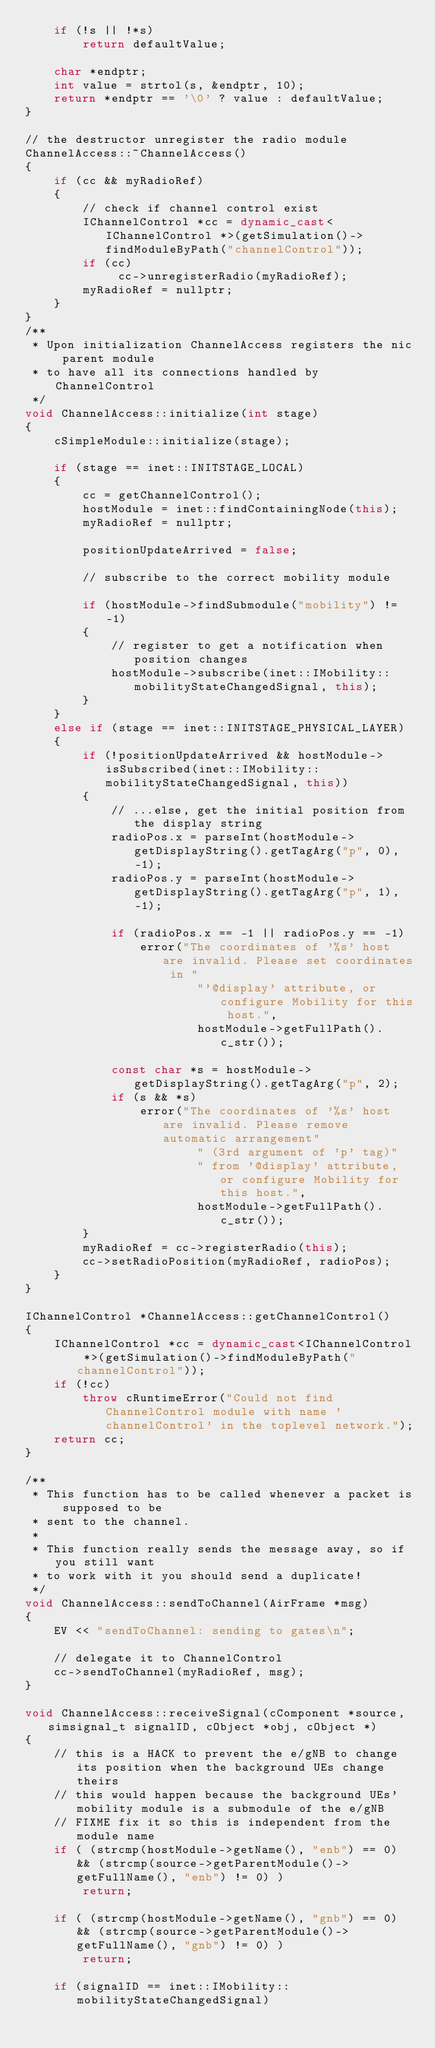Convert code to text. <code><loc_0><loc_0><loc_500><loc_500><_C++_>    if (!s || !*s)
        return defaultValue;

    char *endptr;
    int value = strtol(s, &endptr, 10);
    return *endptr == '\0' ? value : defaultValue;
}

// the destructor unregister the radio module
ChannelAccess::~ChannelAccess()
{
    if (cc && myRadioRef)
    {
        // check if channel control exist
        IChannelControl *cc = dynamic_cast<IChannelControl *>(getSimulation()->findModuleByPath("channelControl"));
        if (cc)
             cc->unregisterRadio(myRadioRef);
        myRadioRef = nullptr;
    }
}
/**
 * Upon initialization ChannelAccess registers the nic parent module
 * to have all its connections handled by ChannelControl
 */
void ChannelAccess::initialize(int stage)
{
    cSimpleModule::initialize(stage);

    if (stage == inet::INITSTAGE_LOCAL)
    {
        cc = getChannelControl();
        hostModule = inet::findContainingNode(this);
        myRadioRef = nullptr;

        positionUpdateArrived = false;

        // subscribe to the correct mobility module

        if (hostModule->findSubmodule("mobility") != -1)
        {
            // register to get a notification when position changes
            hostModule->subscribe(inet::IMobility::mobilityStateChangedSignal, this);
        }
    }
    else if (stage == inet::INITSTAGE_PHYSICAL_LAYER)
    {
        if (!positionUpdateArrived && hostModule->isSubscribed(inet::IMobility::mobilityStateChangedSignal, this))
        {
            // ...else, get the initial position from the display string
            radioPos.x = parseInt(hostModule->getDisplayString().getTagArg("p", 0), -1);
            radioPos.y = parseInt(hostModule->getDisplayString().getTagArg("p", 1), -1);

            if (radioPos.x == -1 || radioPos.y == -1)
                error("The coordinates of '%s' host are invalid. Please set coordinates in "
                        "'@display' attribute, or configure Mobility for this host.",
                        hostModule->getFullPath().c_str());

            const char *s = hostModule->getDisplayString().getTagArg("p", 2);
            if (s && *s)
                error("The coordinates of '%s' host are invalid. Please remove automatic arrangement"
                        " (3rd argument of 'p' tag)"
                        " from '@display' attribute, or configure Mobility for this host.",
                        hostModule->getFullPath().c_str());
        }
        myRadioRef = cc->registerRadio(this);
        cc->setRadioPosition(myRadioRef, radioPos);
    }
}

IChannelControl *ChannelAccess::getChannelControl()
{
    IChannelControl *cc = dynamic_cast<IChannelControl *>(getSimulation()->findModuleByPath("channelControl"));
    if (!cc)
        throw cRuntimeError("Could not find ChannelControl module with name 'channelControl' in the toplevel network.");
    return cc;
}

/**
 * This function has to be called whenever a packet is supposed to be
 * sent to the channel.
 *
 * This function really sends the message away, so if you still want
 * to work with it you should send a duplicate!
 */
void ChannelAccess::sendToChannel(AirFrame *msg)
{
    EV << "sendToChannel: sending to gates\n";

    // delegate it to ChannelControl
    cc->sendToChannel(myRadioRef, msg);
}

void ChannelAccess::receiveSignal(cComponent *source, simsignal_t signalID, cObject *obj, cObject *)
{
    // this is a HACK to prevent the e/gNB to change its position when the background UEs change theirs
    // this would happen because the background UEs' mobility module is a submodule of the e/gNB
    // FIXME fix it so this is independent from the module name
    if ( (strcmp(hostModule->getName(), "enb") == 0) && (strcmp(source->getParentModule()->getFullName(), "enb") != 0) )
        return;

    if ( (strcmp(hostModule->getName(), "gnb") == 0) && (strcmp(source->getParentModule()->getFullName(), "gnb") != 0) )
        return;

    if (signalID == inet::IMobility::mobilityStateChangedSignal)</code> 